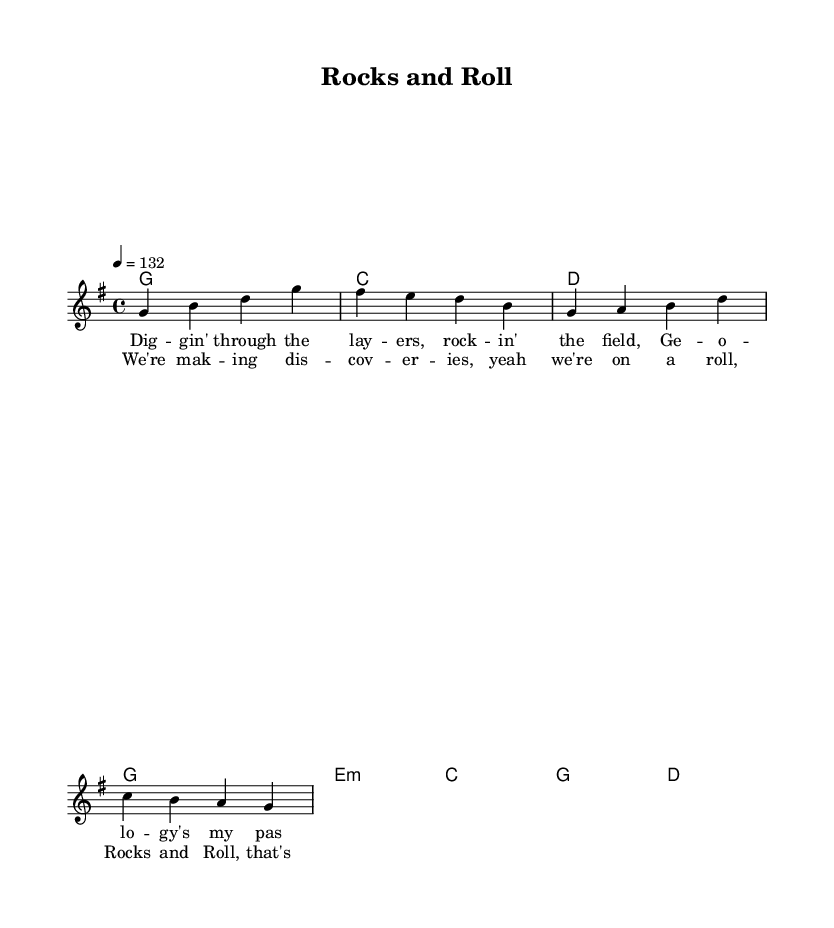What is the key signature of this music? The key signature is G major, which contains one sharp (F#). This can be determined by looking at the first part of the global section where it indicates the key.
Answer: G major What is the time signature of this music? The time signature is 4/4, as indicated in the global section of the code. This means there are four beats in each measure and the quarter note gets one beat.
Answer: 4/4 What is the tempo marking of this music? The tempo marking is 132 beats per minute. This information is found in the global section, where the tempo is specified as "4 = 132".
Answer: 132 What are the first two lyrics of the verse? The first two lyrics of the verse are "Dig -- gin' through". This can be found by looking at the verseOne lyrics section where it begins with the phrase.
Answer: Dig -- gin' through How many chords are used in the harmonies section? There are eight chords used in the harmonies section, which can be counted directly from the chords listed in that part of the code.
Answer: eight Why are upbeat melodies important in Country Rock? Upbeat melodies in Country Rock create a feel-good atmosphere and encourage participation, which aligns with the celebratory theme of academic achievements and scientific discoveries reflected in this piece. This is an inference based on the genre characteristics and the context of the song.
Answer: community engagement What is the title of this piece? The title of the piece is "Rocks and Roll", located in the header section of the code. This is a direct reference to the overall theme of geology combined with the musical style.
Answer: Rocks and Roll 